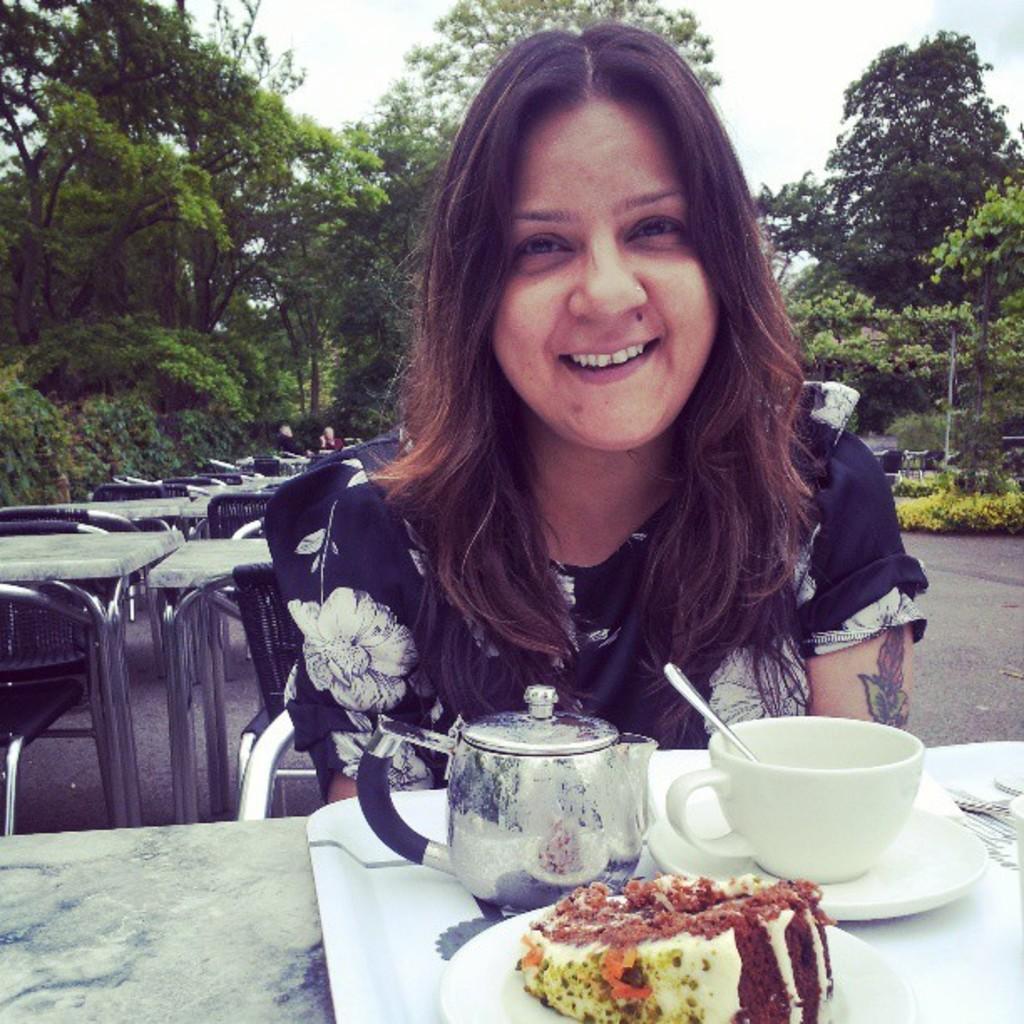How would you summarize this image in a sentence or two? In the center of the image there is a woman sitting at the table. On the table we can see cup, saucer, kettle and pastry. In the background we can see tables, chairs, persons, trees and sky. 